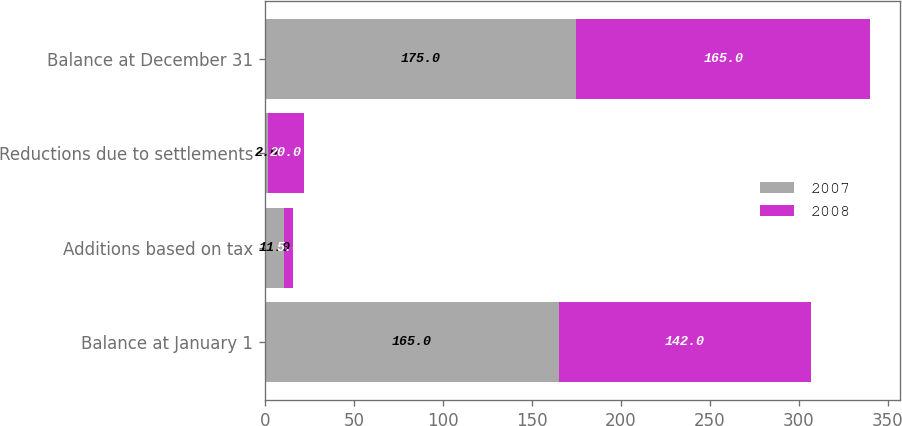Convert chart to OTSL. <chart><loc_0><loc_0><loc_500><loc_500><stacked_bar_chart><ecel><fcel>Balance at January 1<fcel>Additions based on tax<fcel>Reductions due to settlements<fcel>Balance at December 31<nl><fcel>2007<fcel>165<fcel>11<fcel>2<fcel>175<nl><fcel>2008<fcel>142<fcel>5<fcel>20<fcel>165<nl></chart> 